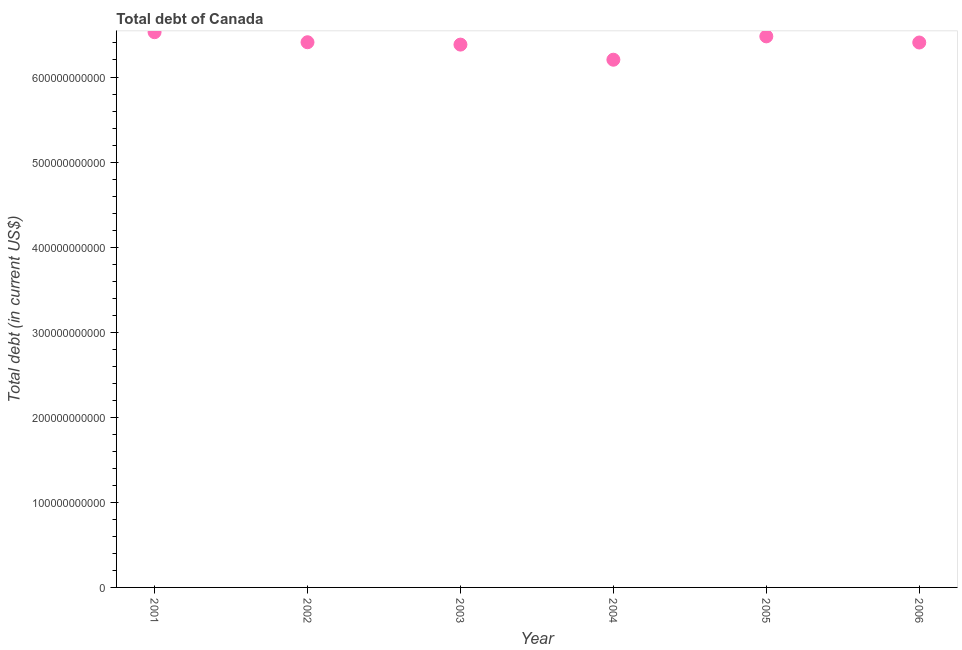What is the total debt in 2004?
Provide a succinct answer. 6.20e+11. Across all years, what is the maximum total debt?
Provide a succinct answer. 6.53e+11. Across all years, what is the minimum total debt?
Your answer should be compact. 6.20e+11. In which year was the total debt maximum?
Ensure brevity in your answer.  2001. In which year was the total debt minimum?
Ensure brevity in your answer.  2004. What is the sum of the total debt?
Give a very brief answer. 3.84e+12. What is the difference between the total debt in 2004 and 2005?
Provide a short and direct response. -2.74e+1. What is the average total debt per year?
Keep it short and to the point. 6.40e+11. What is the median total debt?
Offer a terse response. 6.41e+11. In how many years, is the total debt greater than 100000000000 US$?
Keep it short and to the point. 6. Do a majority of the years between 2003 and 2001 (inclusive) have total debt greater than 420000000000 US$?
Provide a succinct answer. No. What is the ratio of the total debt in 2002 to that in 2003?
Provide a short and direct response. 1. Is the difference between the total debt in 2003 and 2006 greater than the difference between any two years?
Offer a very short reply. No. What is the difference between the highest and the second highest total debt?
Offer a very short reply. 4.92e+09. What is the difference between the highest and the lowest total debt?
Ensure brevity in your answer.  3.23e+1. In how many years, is the total debt greater than the average total debt taken over all years?
Your answer should be very brief. 4. Does the total debt monotonically increase over the years?
Offer a terse response. No. What is the difference between two consecutive major ticks on the Y-axis?
Keep it short and to the point. 1.00e+11. Are the values on the major ticks of Y-axis written in scientific E-notation?
Keep it short and to the point. No. Does the graph contain any zero values?
Keep it short and to the point. No. Does the graph contain grids?
Your answer should be compact. No. What is the title of the graph?
Your answer should be compact. Total debt of Canada. What is the label or title of the X-axis?
Keep it short and to the point. Year. What is the label or title of the Y-axis?
Your response must be concise. Total debt (in current US$). What is the Total debt (in current US$) in 2001?
Ensure brevity in your answer.  6.53e+11. What is the Total debt (in current US$) in 2002?
Your answer should be compact. 6.41e+11. What is the Total debt (in current US$) in 2003?
Provide a short and direct response. 6.38e+11. What is the Total debt (in current US$) in 2004?
Make the answer very short. 6.20e+11. What is the Total debt (in current US$) in 2005?
Ensure brevity in your answer.  6.48e+11. What is the Total debt (in current US$) in 2006?
Offer a very short reply. 6.41e+11. What is the difference between the Total debt (in current US$) in 2001 and 2002?
Offer a very short reply. 1.18e+1. What is the difference between the Total debt (in current US$) in 2001 and 2003?
Ensure brevity in your answer.  1.46e+1. What is the difference between the Total debt (in current US$) in 2001 and 2004?
Your response must be concise. 3.23e+1. What is the difference between the Total debt (in current US$) in 2001 and 2005?
Make the answer very short. 4.92e+09. What is the difference between the Total debt (in current US$) in 2001 and 2006?
Ensure brevity in your answer.  1.21e+1. What is the difference between the Total debt (in current US$) in 2002 and 2003?
Offer a terse response. 2.78e+09. What is the difference between the Total debt (in current US$) in 2002 and 2004?
Keep it short and to the point. 2.05e+1. What is the difference between the Total debt (in current US$) in 2002 and 2005?
Your answer should be very brief. -6.89e+09. What is the difference between the Total debt (in current US$) in 2002 and 2006?
Ensure brevity in your answer.  3.21e+08. What is the difference between the Total debt (in current US$) in 2003 and 2004?
Offer a very short reply. 1.78e+1. What is the difference between the Total debt (in current US$) in 2003 and 2005?
Keep it short and to the point. -9.66e+09. What is the difference between the Total debt (in current US$) in 2003 and 2006?
Your answer should be compact. -2.46e+09. What is the difference between the Total debt (in current US$) in 2004 and 2005?
Your answer should be compact. -2.74e+1. What is the difference between the Total debt (in current US$) in 2004 and 2006?
Your answer should be compact. -2.02e+1. What is the difference between the Total debt (in current US$) in 2005 and 2006?
Your answer should be compact. 7.21e+09. What is the ratio of the Total debt (in current US$) in 2001 to that in 2002?
Your answer should be very brief. 1.02. What is the ratio of the Total debt (in current US$) in 2001 to that in 2004?
Give a very brief answer. 1.05. What is the ratio of the Total debt (in current US$) in 2002 to that in 2004?
Offer a very short reply. 1.03. What is the ratio of the Total debt (in current US$) in 2002 to that in 2006?
Offer a very short reply. 1. What is the ratio of the Total debt (in current US$) in 2004 to that in 2005?
Your answer should be compact. 0.96. What is the ratio of the Total debt (in current US$) in 2005 to that in 2006?
Offer a terse response. 1.01. 